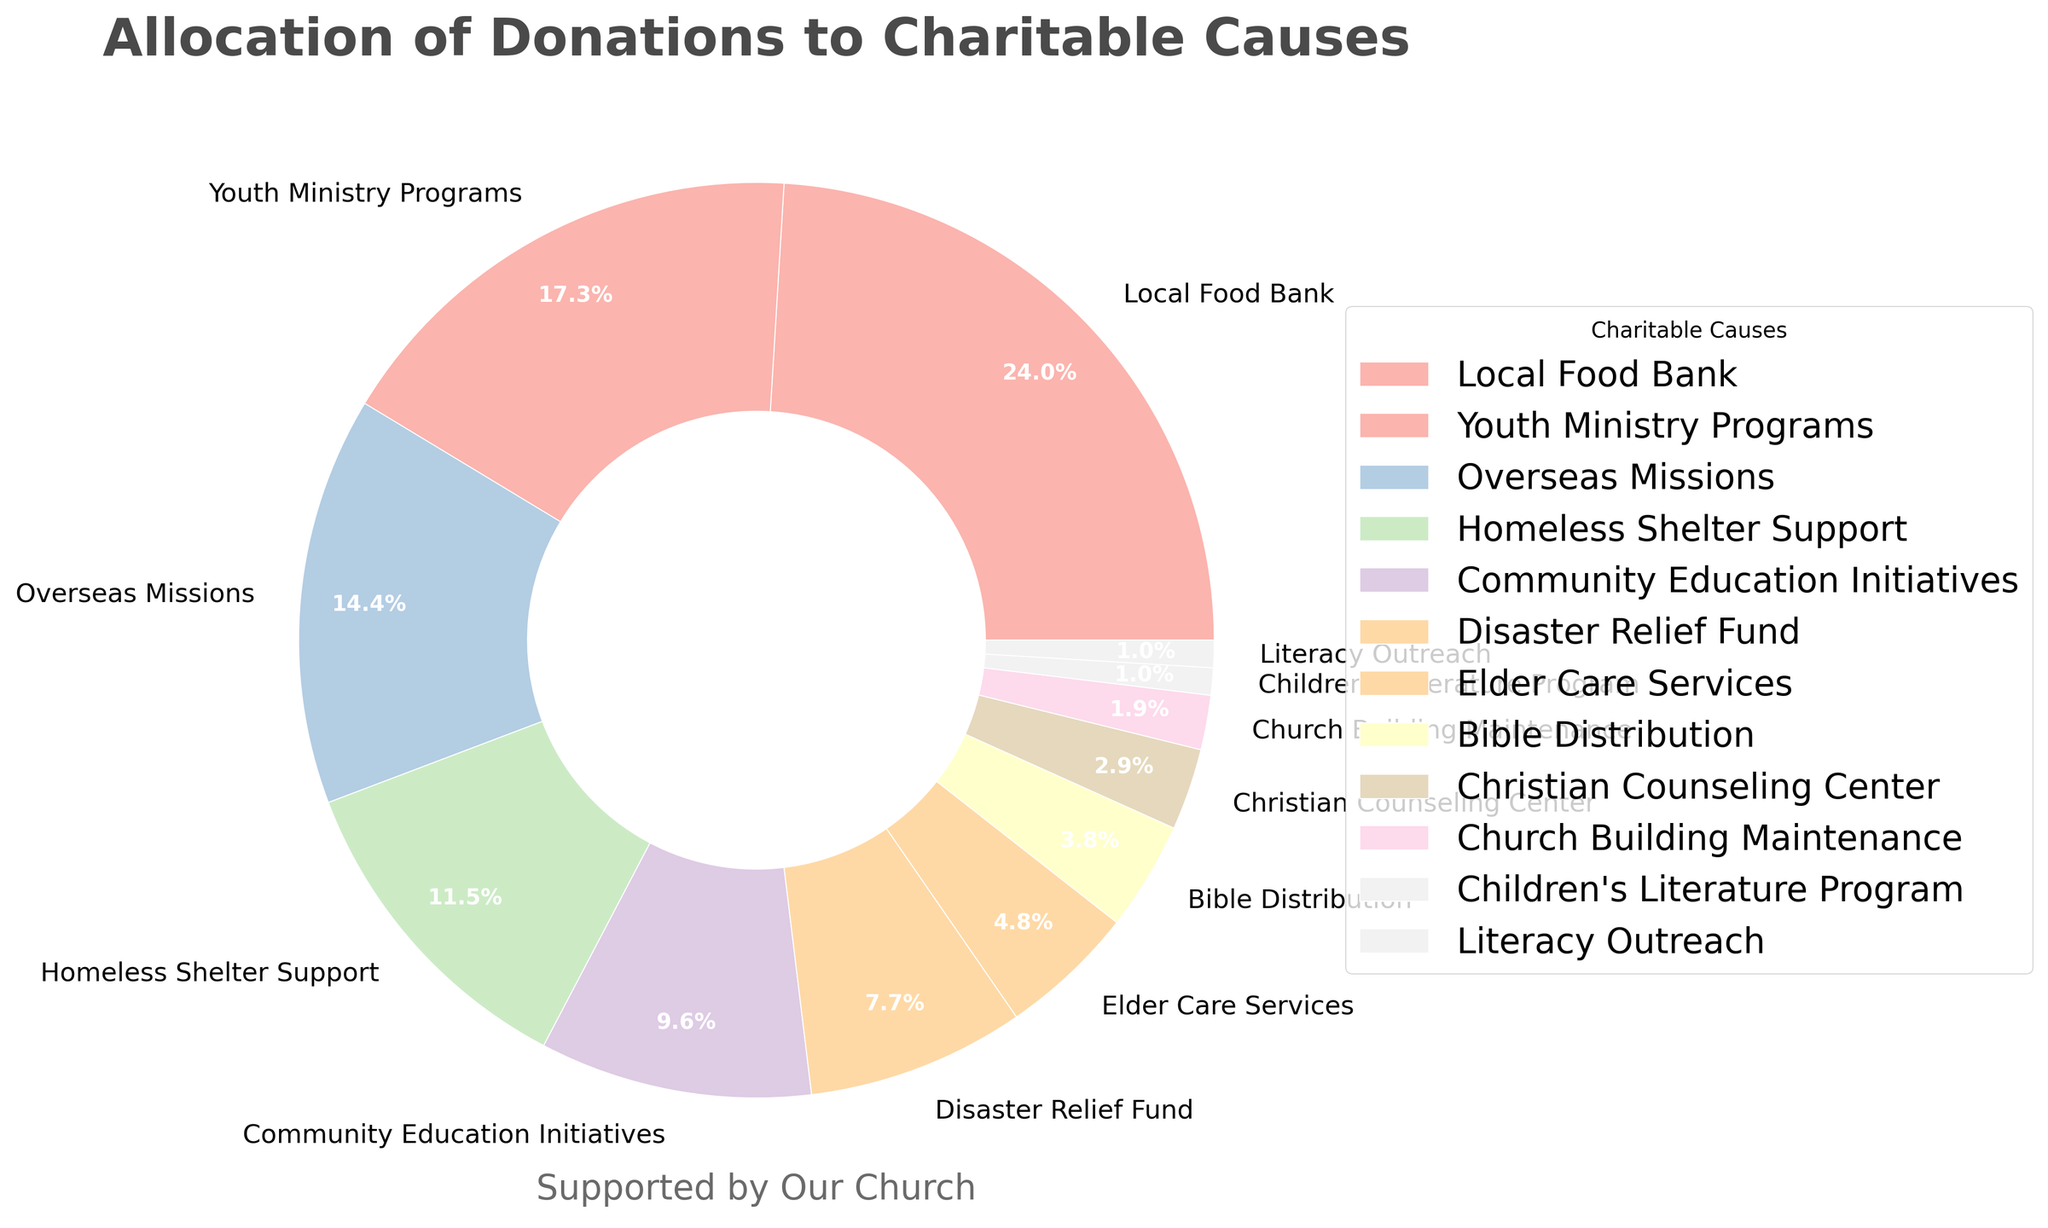What is the percentage allocated to the Local Food Bank? The Local Food Bank's percentage is found directly on the pie chart segment labeled "Local Food Bank".
Answer: 25% Which cause received the least amount of donations? Look for the segment with the smallest percentage value or the smallest visual slice.
Answer: Literacy Outreach and Children's Literature Program Compare the percentages of Youth Ministry Programs and Overseas Missions. Which one is higher and by how much? Identify the percentages for Youth Ministry Programs (18%) and Overseas Missions (15%) on the pie chart. Subtract the smaller from the larger value to find the difference.
Answer: Youth Ministry Programs by 3% What are the total percentages allocated to Elder Care Services, Bible Distribution, and the Christian Counseling Center? Summing up the individual percentages for Elder Care Services (5%), Bible Distribution (4%), and the Christian Counseling Center (3%).
Answer: 12% Identify two causes that collectively use up 20% of donations. Several combinations are possible but one way is to combine the data. For instance, combining Community Education Initiatives (10%) and Disaster Relief Fund (8%) gives a sum of 18%. Instead, combining Overseas Missions (15%) and Church Building Maintenance (2%) results in 17%. Finally, combining Literacy Outreach (1%) and Children's Literature Program (1%) gives 2%. Another accurate combination is combining Elder Care Services (5%) and Bible Distribution (4%) and Christian Counseling Center (3%) and Church Building Maintenance (2%) (5% + 4% + 3% + 2%) results in exactly 14%. Therefore it is challenging to find exactly 20%. If we can combine three causes then Elder Care Services (5%), Bible Distribution (4%), and Christian Counseling Center (3%) and Disaster Relief Fund (8%).
Answer: Elder Care Services, Bible Distribution, Disaster Relief Fund, and Christian Counseling Center What is the total percentage given to education-related causes? From the pie chart, Community Education Initiatives (10%), Literacy Outreach (1%), and Children's Literature Program (1%) sum to education-related donations. Summing these values: 10+1+1.
Answer: 12% Which caused received more donations, the Disaster Relief Fund or Community Education Initiatives? Compare the two percentages: Disaster Relief Fund (8%) and Community Education Initiatives (10%).
Answer: Community Education Initiatives How much larger is the Local Food Bank's slice compared to the Elder Care Services' slice in percentage terms? Subtract the percentage for Elder Care Services (5%) from Local Food Bank (25%).
Answer: 20% What is the combined total percentage of the three largest causes? The three largest causes are Local Food Bank (25%), Youth Ministry Programs (18%), and Overseas Missions (15%). Summing them up: 25+18+15.
Answer: 58% What fraction of donations go to support overseas activities? The slice for Overseas Missions (15%) out of the total 100% gives us 15/100.
Answer: 15% 